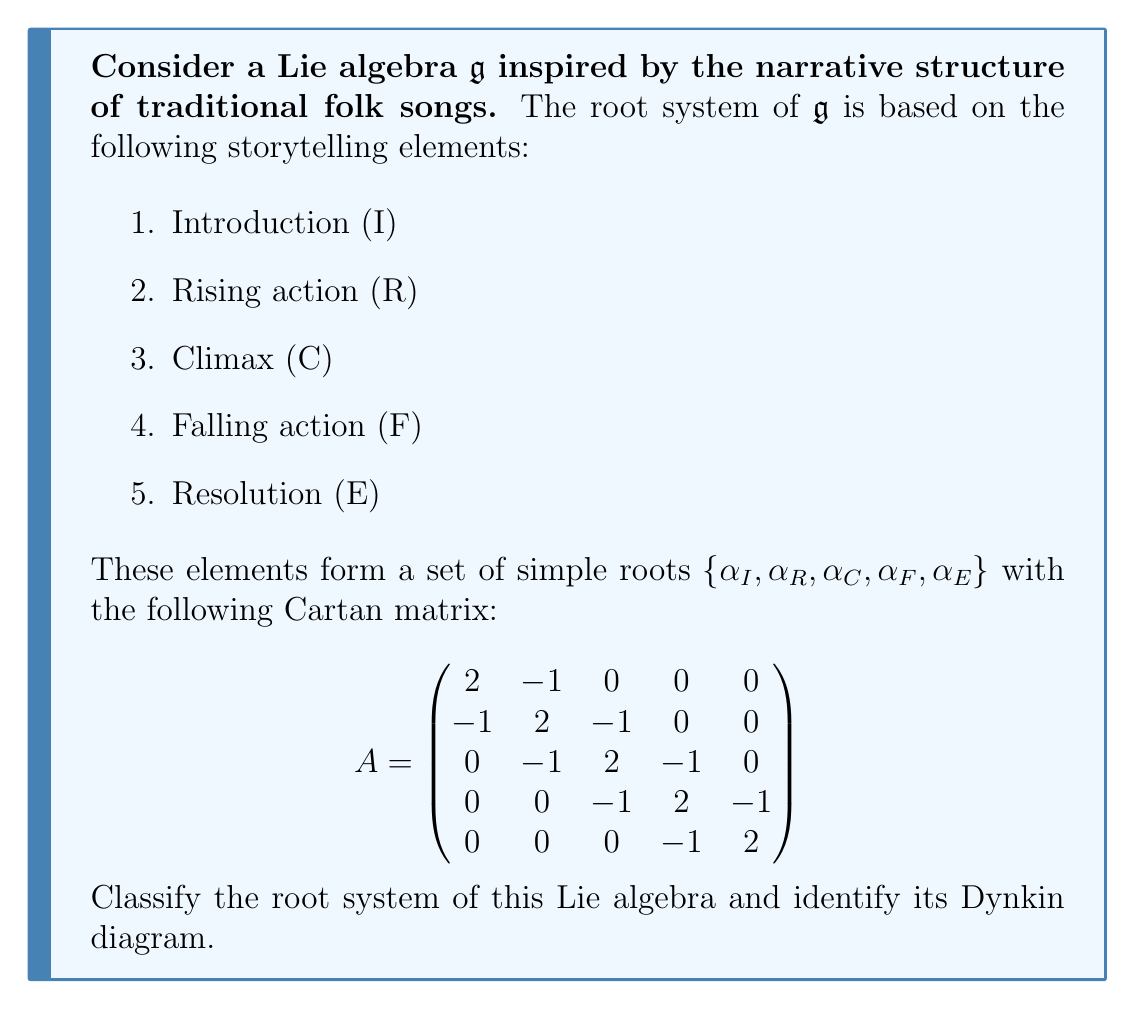Can you solve this math problem? To classify the root system and identify the Dynkin diagram, we'll follow these steps:

1. Analyze the Cartan matrix:
   The Cartan matrix $A$ is symmetric and has 2's on the diagonal, which indicates that all simple roots have the same length. Off-diagonal elements are either 0 or -1, suggesting single bonds between connected nodes in the Dynkin diagram.

2. Count the number of simple roots:
   There are 5 simple roots, corresponding to the 5x5 Cartan matrix.

3. Examine the connectivity:
   The matrix shows that each root is connected to at most two other roots, forming a linear chain.

4. Identify the Dynkin diagram:
   Based on the Cartan matrix, we can draw the Dynkin diagram:

   [asy]
   unitsize(1cm);
   
   for(int i=0; i<5; ++i) {
     dot((i,0));
     label("$\alpha_"+(string)(i+1)+"$", (i,-0.5));
   }
   
   for(int i=0; i<4; ++i) {
     draw((i,0)--(i+1,0));
   }
   [/asy]

   This is a linear Dynkin diagram with 5 nodes, where each node is connected to its neighbors by single bonds.

5. Classify the root system:
   The Dynkin diagram we've identified corresponds to the $A_5$ root system. This is part of the classical series $A_n$, which is associated with the special linear Lie algebra $\mathfrak{sl}(n+1, \mathbb{C})$.

6. Properties of $A_5$:
   - Rank: 5
   - Dimension of the Lie algebra: 35
   - Number of positive roots: 15
   - Weyl group: Symmetric group $S_6$

Therefore, the Lie algebra $\mathfrak{g}$ derived from the ancestral storytelling structure has a root system isomorphic to $A_5$.
Answer: The root system of the given Lie algebra $\mathfrak{g}$ is classified as $A_5$, with the corresponding Dynkin diagram being a linear chain of 5 nodes connected by single bonds. 